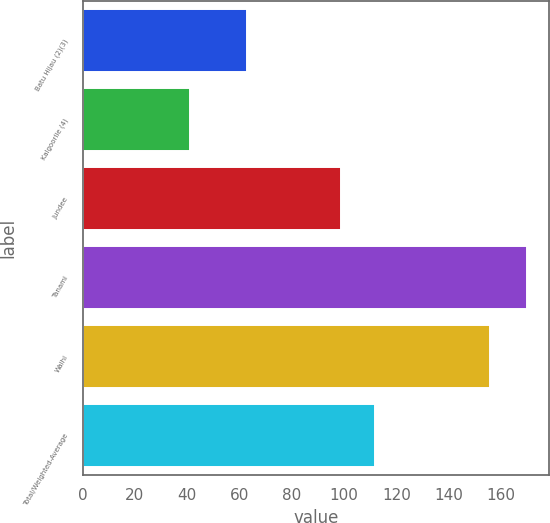Convert chart. <chart><loc_0><loc_0><loc_500><loc_500><bar_chart><fcel>Batu Hijau (2)(3)<fcel>Kalgoorlie (4)<fcel>Jundee<fcel>Tanami<fcel>Waihi<fcel>Total/Weighted-Average<nl><fcel>63<fcel>41<fcel>99<fcel>170<fcel>156<fcel>111.9<nl></chart> 